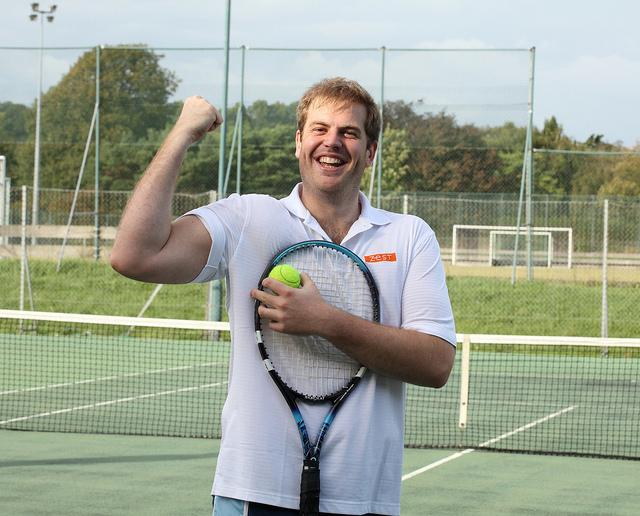What does the man show off here? muscles 